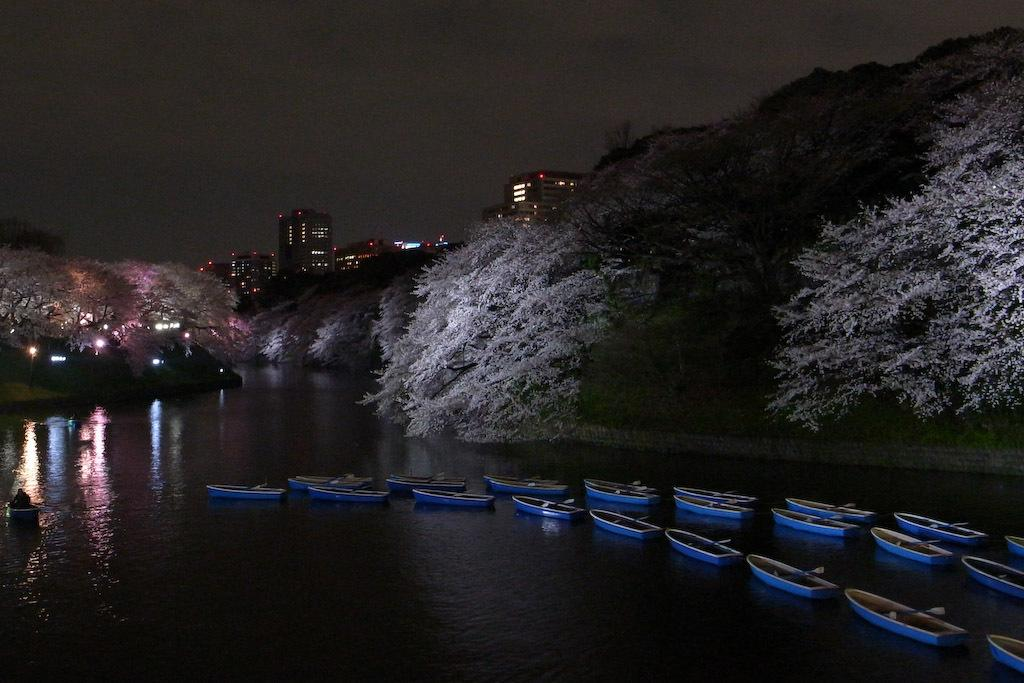What type of vehicles can be seen on the water in the image? There are boats on the water in the image. What type of natural vegetation is visible in the image? There are trees visible in the image. What type of man-made structures can be seen in the image? There are buildings visible in the image. What part of the natural environment is visible in the image? The sky is visible in the image. Can you see a locket hanging from the trees in the image? There is no locket hanging from the trees in the image. How does the start of the day affect the image? The image does not depict a specific time of day, so it is not possible to determine how the start of the day might affect it. 